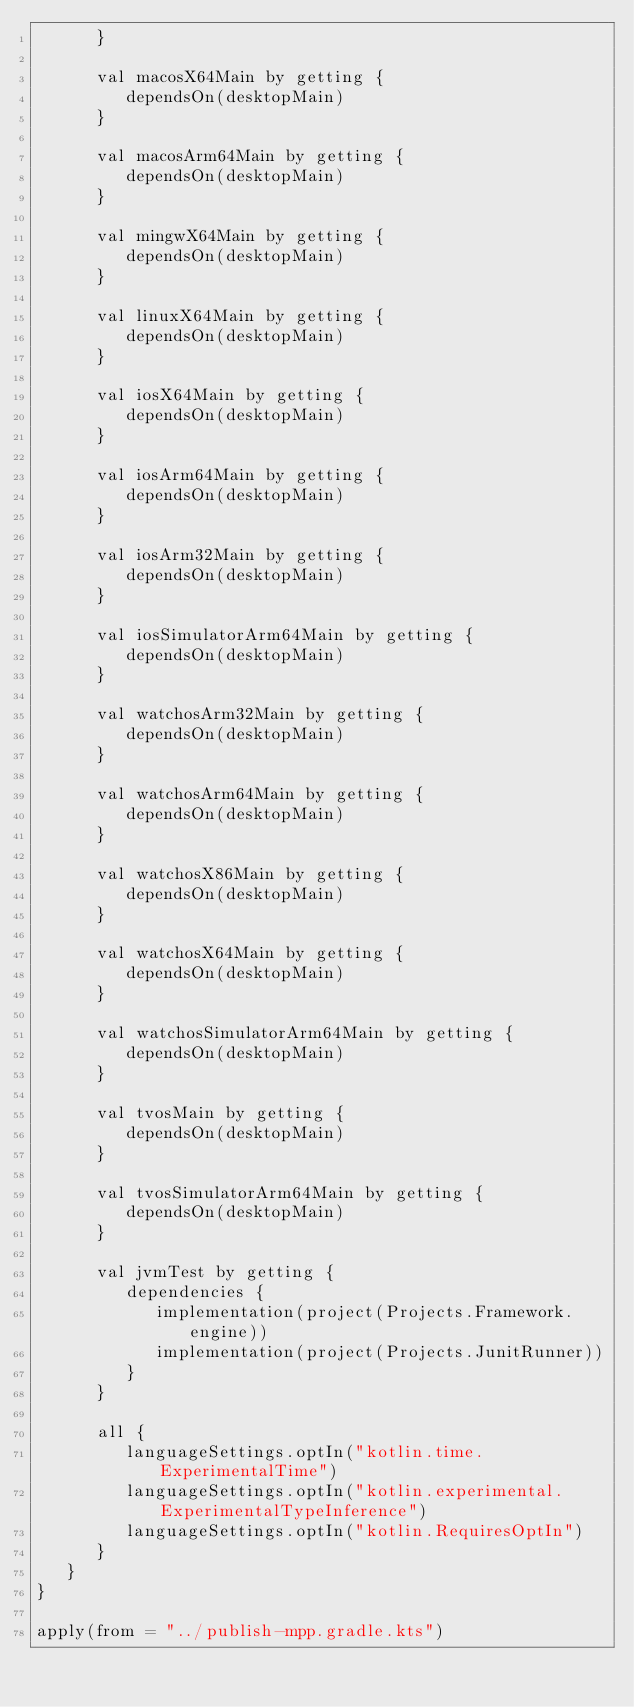<code> <loc_0><loc_0><loc_500><loc_500><_Kotlin_>      }

      val macosX64Main by getting {
         dependsOn(desktopMain)
      }

      val macosArm64Main by getting {
         dependsOn(desktopMain)
      }

      val mingwX64Main by getting {
         dependsOn(desktopMain)
      }

      val linuxX64Main by getting {
         dependsOn(desktopMain)
      }

      val iosX64Main by getting {
         dependsOn(desktopMain)
      }

      val iosArm64Main by getting {
         dependsOn(desktopMain)
      }

      val iosArm32Main by getting {
         dependsOn(desktopMain)
      }

      val iosSimulatorArm64Main by getting {
         dependsOn(desktopMain)
      }

      val watchosArm32Main by getting {
         dependsOn(desktopMain)
      }

      val watchosArm64Main by getting {
         dependsOn(desktopMain)
      }

      val watchosX86Main by getting {
         dependsOn(desktopMain)
      }

      val watchosX64Main by getting {
         dependsOn(desktopMain)
      }

      val watchosSimulatorArm64Main by getting {
         dependsOn(desktopMain)
      }

      val tvosMain by getting {
         dependsOn(desktopMain)
      }

      val tvosSimulatorArm64Main by getting {
         dependsOn(desktopMain)
      }

      val jvmTest by getting {
         dependencies {
            implementation(project(Projects.Framework.engine))
            implementation(project(Projects.JunitRunner))
         }
      }

      all {
         languageSettings.optIn("kotlin.time.ExperimentalTime")
         languageSettings.optIn("kotlin.experimental.ExperimentalTypeInference")
         languageSettings.optIn("kotlin.RequiresOptIn")
      }
   }
}

apply(from = "../publish-mpp.gradle.kts")
</code> 